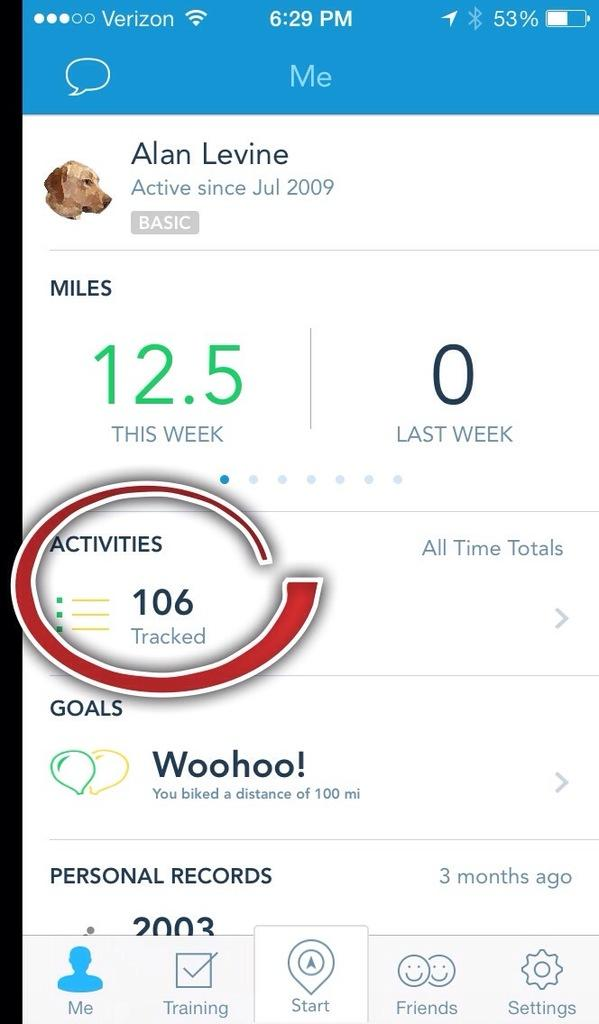<image>
Offer a succinct explanation of the picture presented. A person's miles and activity tracked on a personal app on their phone. 